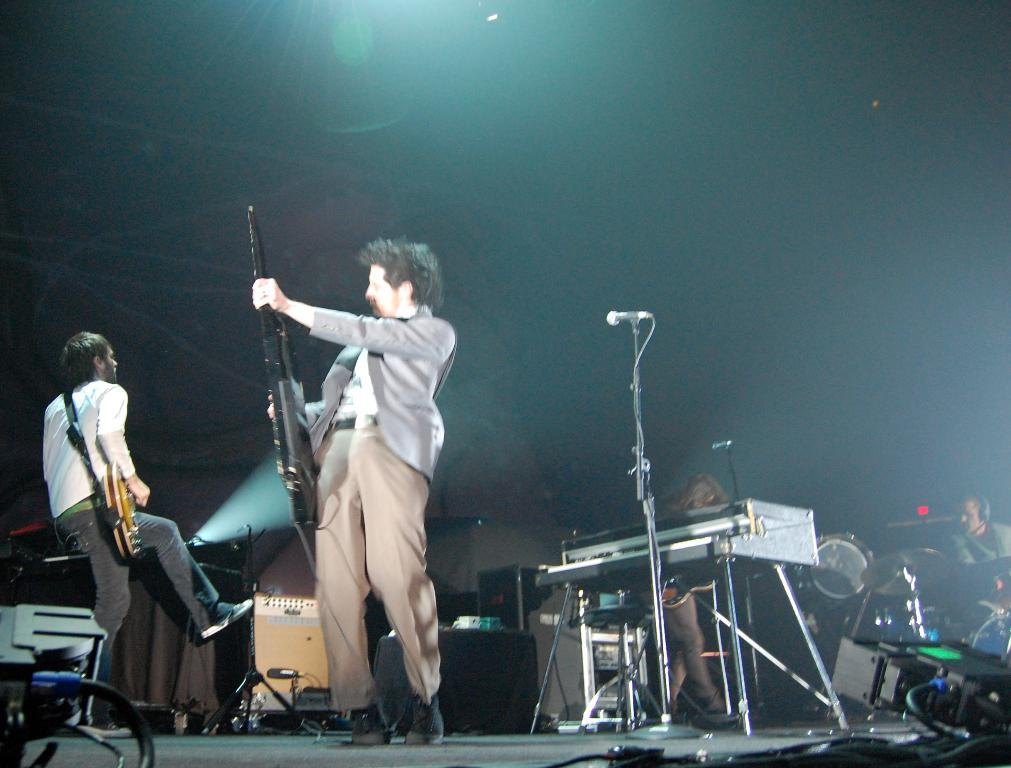What is happening in the image? There are people on stage in the image. What are the people on stage doing? They are likely performing, as musical instruments and microphones are present in the image. Can you describe any specific features of the stage setup? Yes, there are wires visible in the image, which may be connected to the musical instruments or microphones. What is the lighting like in the image? The background of the image is dark, which may suggest that the performance is taking place in a dimly lit environment. What type of jewel can be seen in the eye of the person on stage? There is no jewel visible in the eye of any person on stage in the image. What does the stage smell like during the performance? The image does not provide any information about the smell of the stage during the performance. 